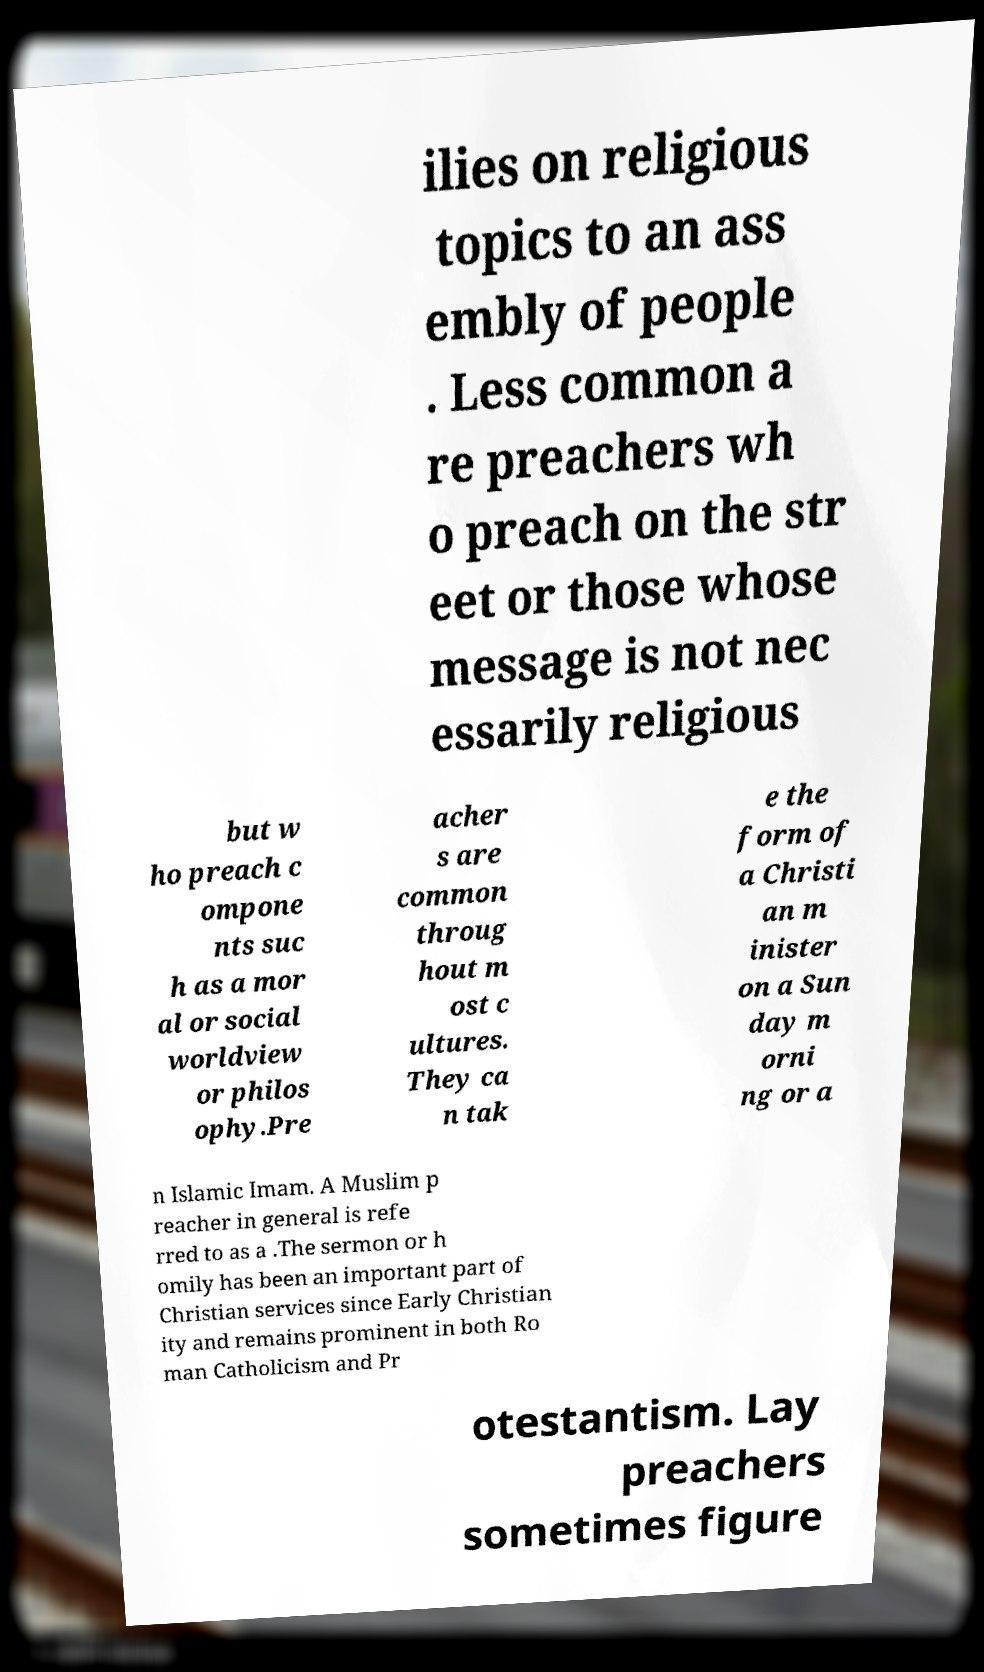For documentation purposes, I need the text within this image transcribed. Could you provide that? ilies on religious topics to an ass embly of people . Less common a re preachers wh o preach on the str eet or those whose message is not nec essarily religious but w ho preach c ompone nts suc h as a mor al or social worldview or philos ophy.Pre acher s are common throug hout m ost c ultures. They ca n tak e the form of a Christi an m inister on a Sun day m orni ng or a n Islamic Imam. A Muslim p reacher in general is refe rred to as a .The sermon or h omily has been an important part of Christian services since Early Christian ity and remains prominent in both Ro man Catholicism and Pr otestantism. Lay preachers sometimes figure 